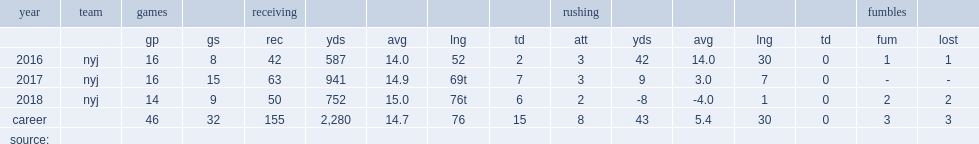How many receptions did robby anderson get in 2017? 63.0. 